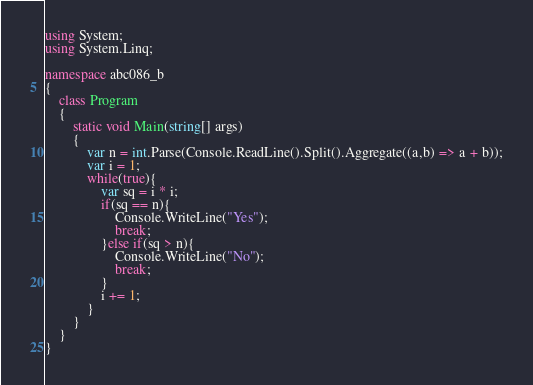Convert code to text. <code><loc_0><loc_0><loc_500><loc_500><_C#_>using System;
using System.Linq;

namespace abc086_b
{
    class Program
    {
        static void Main(string[] args)
        {
            var n = int.Parse(Console.ReadLine().Split().Aggregate((a,b) => a + b));
            var i = 1;
            while(true){
                var sq = i * i;
                if(sq == n){
                    Console.WriteLine("Yes");
                    break;
                }else if(sq > n){
                    Console.WriteLine("No");
                    break;
                }
                i += 1;
            }
        }
    }
}
</code> 